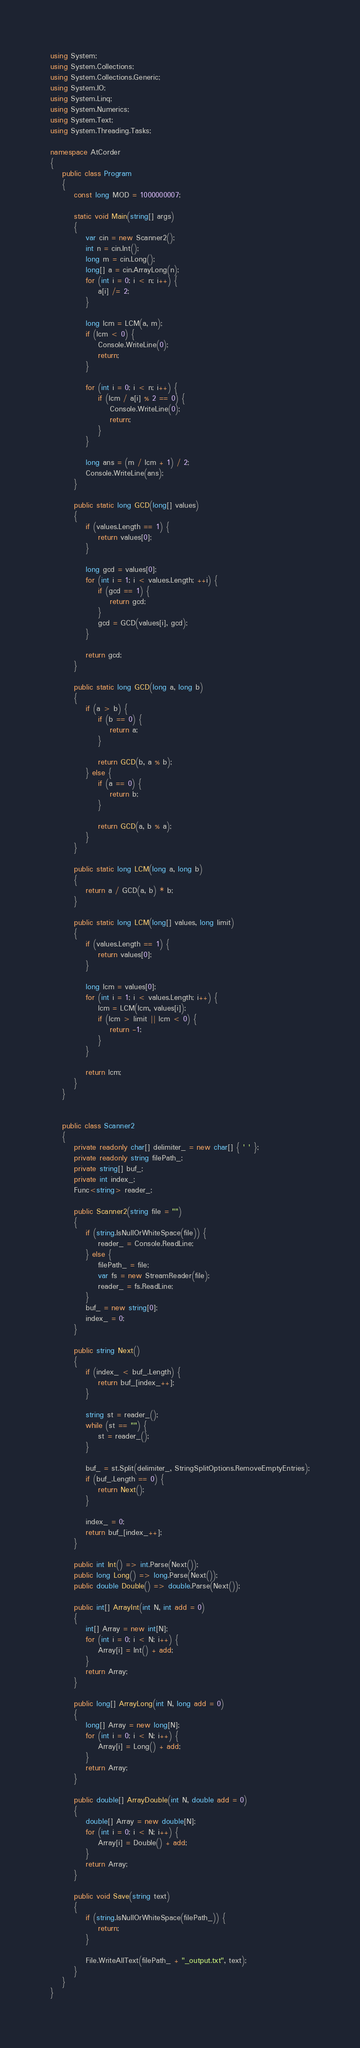<code> <loc_0><loc_0><loc_500><loc_500><_C#_>using System;
using System.Collections;
using System.Collections.Generic;
using System.IO;
using System.Linq;
using System.Numerics;
using System.Text;
using System.Threading.Tasks;

namespace AtCorder
{
	public class Program
	{
		const long MOD = 1000000007;

		static void Main(string[] args)
		{
			var cin = new Scanner2();
			int n = cin.Int();
			long m = cin.Long();
			long[] a = cin.ArrayLong(n);
			for (int i = 0; i < n; i++) {
				a[i] /= 2;
			}

			long lcm = LCM(a, m);
			if (lcm < 0) {
				Console.WriteLine(0);
				return;
			}

			for (int i = 0; i < n; i++) {
				if (lcm / a[i] % 2 == 0) {
					Console.WriteLine(0);
					return;
				}
			}

			long ans = (m / lcm + 1) / 2;
			Console.WriteLine(ans);
		}

		public static long GCD(long[] values)
		{
			if (values.Length == 1) {
				return values[0];
			}

			long gcd = values[0];
			for (int i = 1; i < values.Length; ++i) {
				if (gcd == 1) {
					return gcd;
				}
				gcd = GCD(values[i], gcd);
			}

			return gcd;
		}

		public static long GCD(long a, long b)
		{
			if (a > b) {
				if (b == 0) {
					return a;
				}

				return GCD(b, a % b);
			} else {
				if (a == 0) {
					return b;
				}

				return GCD(a, b % a);
			}
		}

		public static long LCM(long a, long b)
		{
			return a / GCD(a, b) * b;
		}

		public static long LCM(long[] values, long limit)
		{
			if (values.Length == 1) {
				return values[0];
			}

			long lcm = values[0];
			for (int i = 1; i < values.Length; i++) {
				lcm = LCM(lcm, values[i]);
				if (lcm > limit || lcm < 0) {
					return -1;
				}
			}

			return lcm;
		}
	}


	public class Scanner2
	{
		private readonly char[] delimiter_ = new char[] { ' ' };
		private readonly string filePath_;
		private string[] buf_;
		private int index_;
		Func<string> reader_;

		public Scanner2(string file = "")
		{
			if (string.IsNullOrWhiteSpace(file)) {
				reader_ = Console.ReadLine;
			} else {
				filePath_ = file;
				var fs = new StreamReader(file);
				reader_ = fs.ReadLine;
			}
			buf_ = new string[0];
			index_ = 0;
		}

		public string Next()
		{
			if (index_ < buf_.Length) {
				return buf_[index_++];
			}

			string st = reader_();
			while (st == "") {
				st = reader_();
			}

			buf_ = st.Split(delimiter_, StringSplitOptions.RemoveEmptyEntries);
			if (buf_.Length == 0) {
				return Next();
			}

			index_ = 0;
			return buf_[index_++];
		}

		public int Int() => int.Parse(Next());
		public long Long() => long.Parse(Next());
		public double Double() => double.Parse(Next());

		public int[] ArrayInt(int N, int add = 0)
		{
			int[] Array = new int[N];
			for (int i = 0; i < N; i++) {
				Array[i] = Int() + add;
			}
			return Array;
		}

		public long[] ArrayLong(int N, long add = 0)
		{
			long[] Array = new long[N];
			for (int i = 0; i < N; i++) {
				Array[i] = Long() + add;
			}
			return Array;
		}

		public double[] ArrayDouble(int N, double add = 0)
		{
			double[] Array = new double[N];
			for (int i = 0; i < N; i++) {
				Array[i] = Double() + add;
			}
			return Array;
		}

		public void Save(string text)
		{
			if (string.IsNullOrWhiteSpace(filePath_)) {
				return;
			}

			File.WriteAllText(filePath_ + "_output.txt", text);
		}
	}
}</code> 